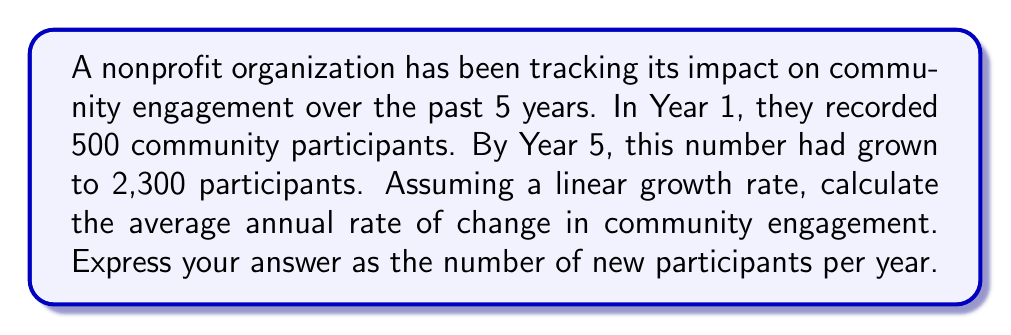Provide a solution to this math problem. To calculate the average annual rate of change, we'll use the formula:

$$ \text{Rate of change} = \frac{\text{Change in y}}{\text{Change in x}} $$

Where:
- Change in y = Final value - Initial value
- Change in x = Time period

Step 1: Identify the values
- Initial value (Year 1): 500 participants
- Final value (Year 5): 2,300 participants
- Time period: 5 years - 1 year = 4 years

Step 2: Calculate the change in y (total change in participants)
$$ \text{Change in y} = 2,300 - 500 = 1,800 \text{ participants} $$

Step 3: Apply the rate of change formula
$$ \text{Rate of change} = \frac{1,800 \text{ participants}}{4 \text{ years}} = 450 \text{ participants per year} $$

Therefore, the average annual rate of change in community engagement is 450 new participants per year.
Answer: 450 participants/year 